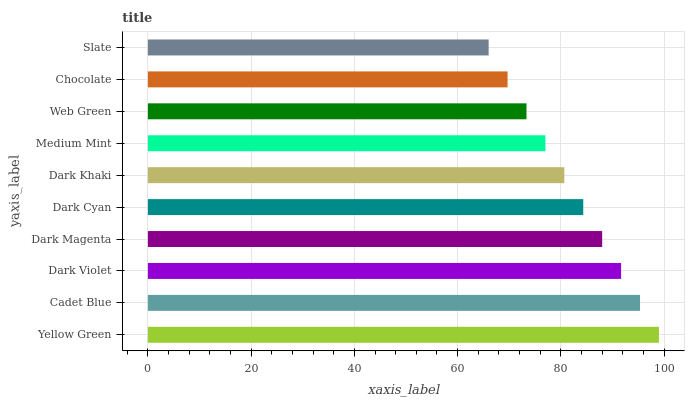Is Slate the minimum?
Answer yes or no. Yes. Is Yellow Green the maximum?
Answer yes or no. Yes. Is Cadet Blue the minimum?
Answer yes or no. No. Is Cadet Blue the maximum?
Answer yes or no. No. Is Yellow Green greater than Cadet Blue?
Answer yes or no. Yes. Is Cadet Blue less than Yellow Green?
Answer yes or no. Yes. Is Cadet Blue greater than Yellow Green?
Answer yes or no. No. Is Yellow Green less than Cadet Blue?
Answer yes or no. No. Is Dark Cyan the high median?
Answer yes or no. Yes. Is Dark Khaki the low median?
Answer yes or no. Yes. Is Cadet Blue the high median?
Answer yes or no. No. Is Chocolate the low median?
Answer yes or no. No. 